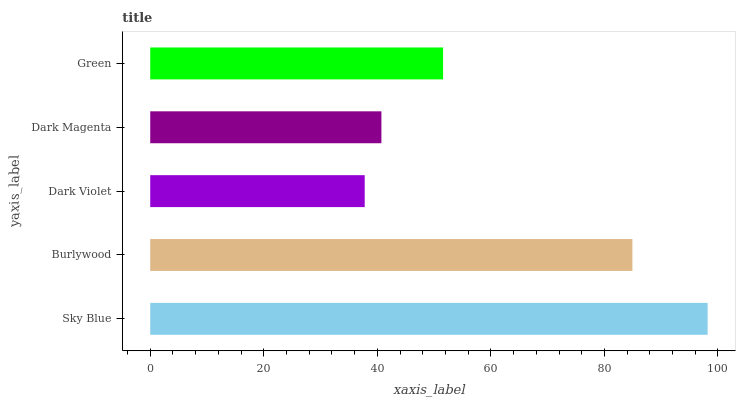Is Dark Violet the minimum?
Answer yes or no. Yes. Is Sky Blue the maximum?
Answer yes or no. Yes. Is Burlywood the minimum?
Answer yes or no. No. Is Burlywood the maximum?
Answer yes or no. No. Is Sky Blue greater than Burlywood?
Answer yes or no. Yes. Is Burlywood less than Sky Blue?
Answer yes or no. Yes. Is Burlywood greater than Sky Blue?
Answer yes or no. No. Is Sky Blue less than Burlywood?
Answer yes or no. No. Is Green the high median?
Answer yes or no. Yes. Is Green the low median?
Answer yes or no. Yes. Is Dark Magenta the high median?
Answer yes or no. No. Is Sky Blue the low median?
Answer yes or no. No. 